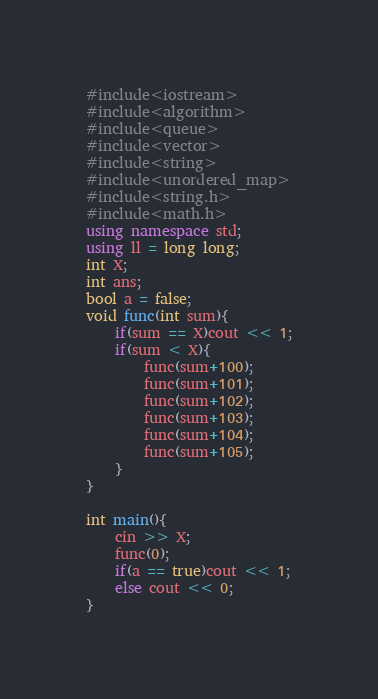Convert code to text. <code><loc_0><loc_0><loc_500><loc_500><_C++_>#include<iostream>
#include<algorithm>
#include<queue>
#include<vector>
#include<string>
#include<unordered_map>
#include<string.h>
#include<math.h>
using namespace std;
using ll = long long;
int X;
int ans;
bool a = false;
void func(int sum){
    if(sum == X)cout << 1;
    if(sum < X){
        func(sum+100);
        func(sum+101);
        func(sum+102);
        func(sum+103);
        func(sum+104);
        func(sum+105);
    }
}

int main(){
    cin >> X;
    func(0);
    if(a == true)cout << 1;
    else cout << 0;
}
</code> 